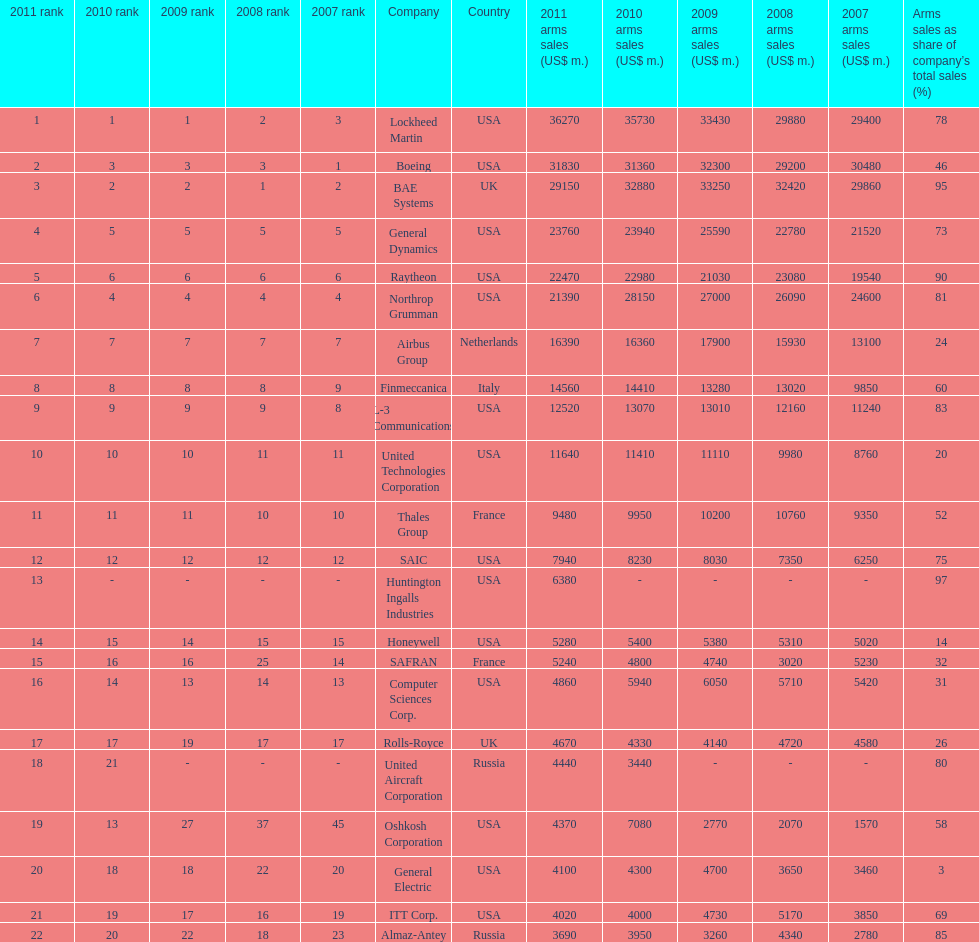In 2010, who has the least amount of sales? United Aircraft Corporation. 